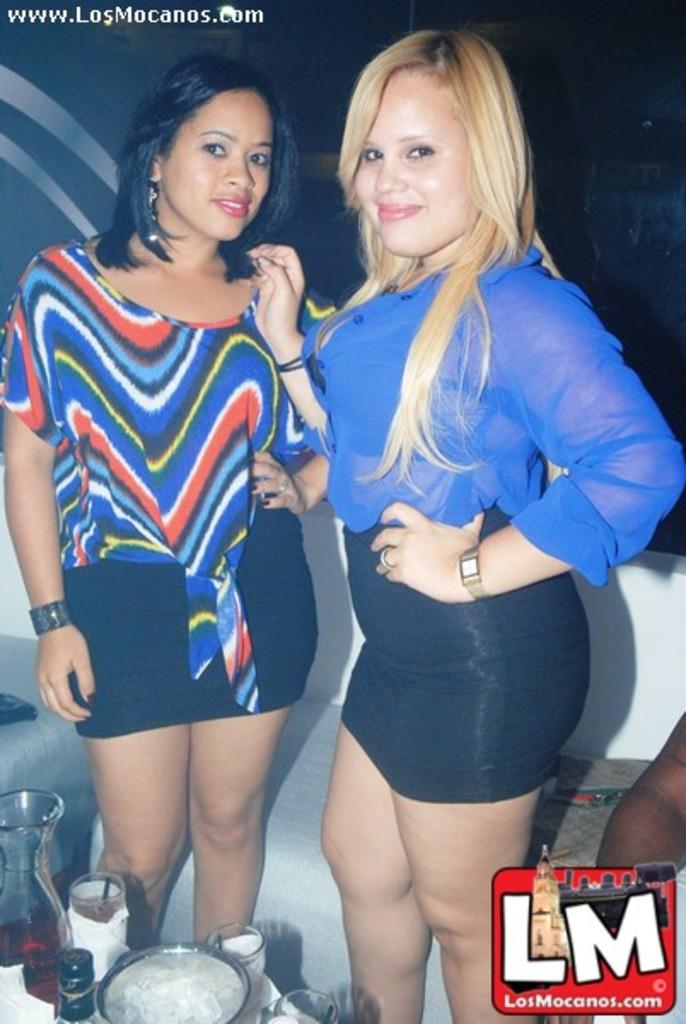<image>
Share a concise interpretation of the image provided. Two women getting their photo taken together, source is www.LosMocanos.com. 